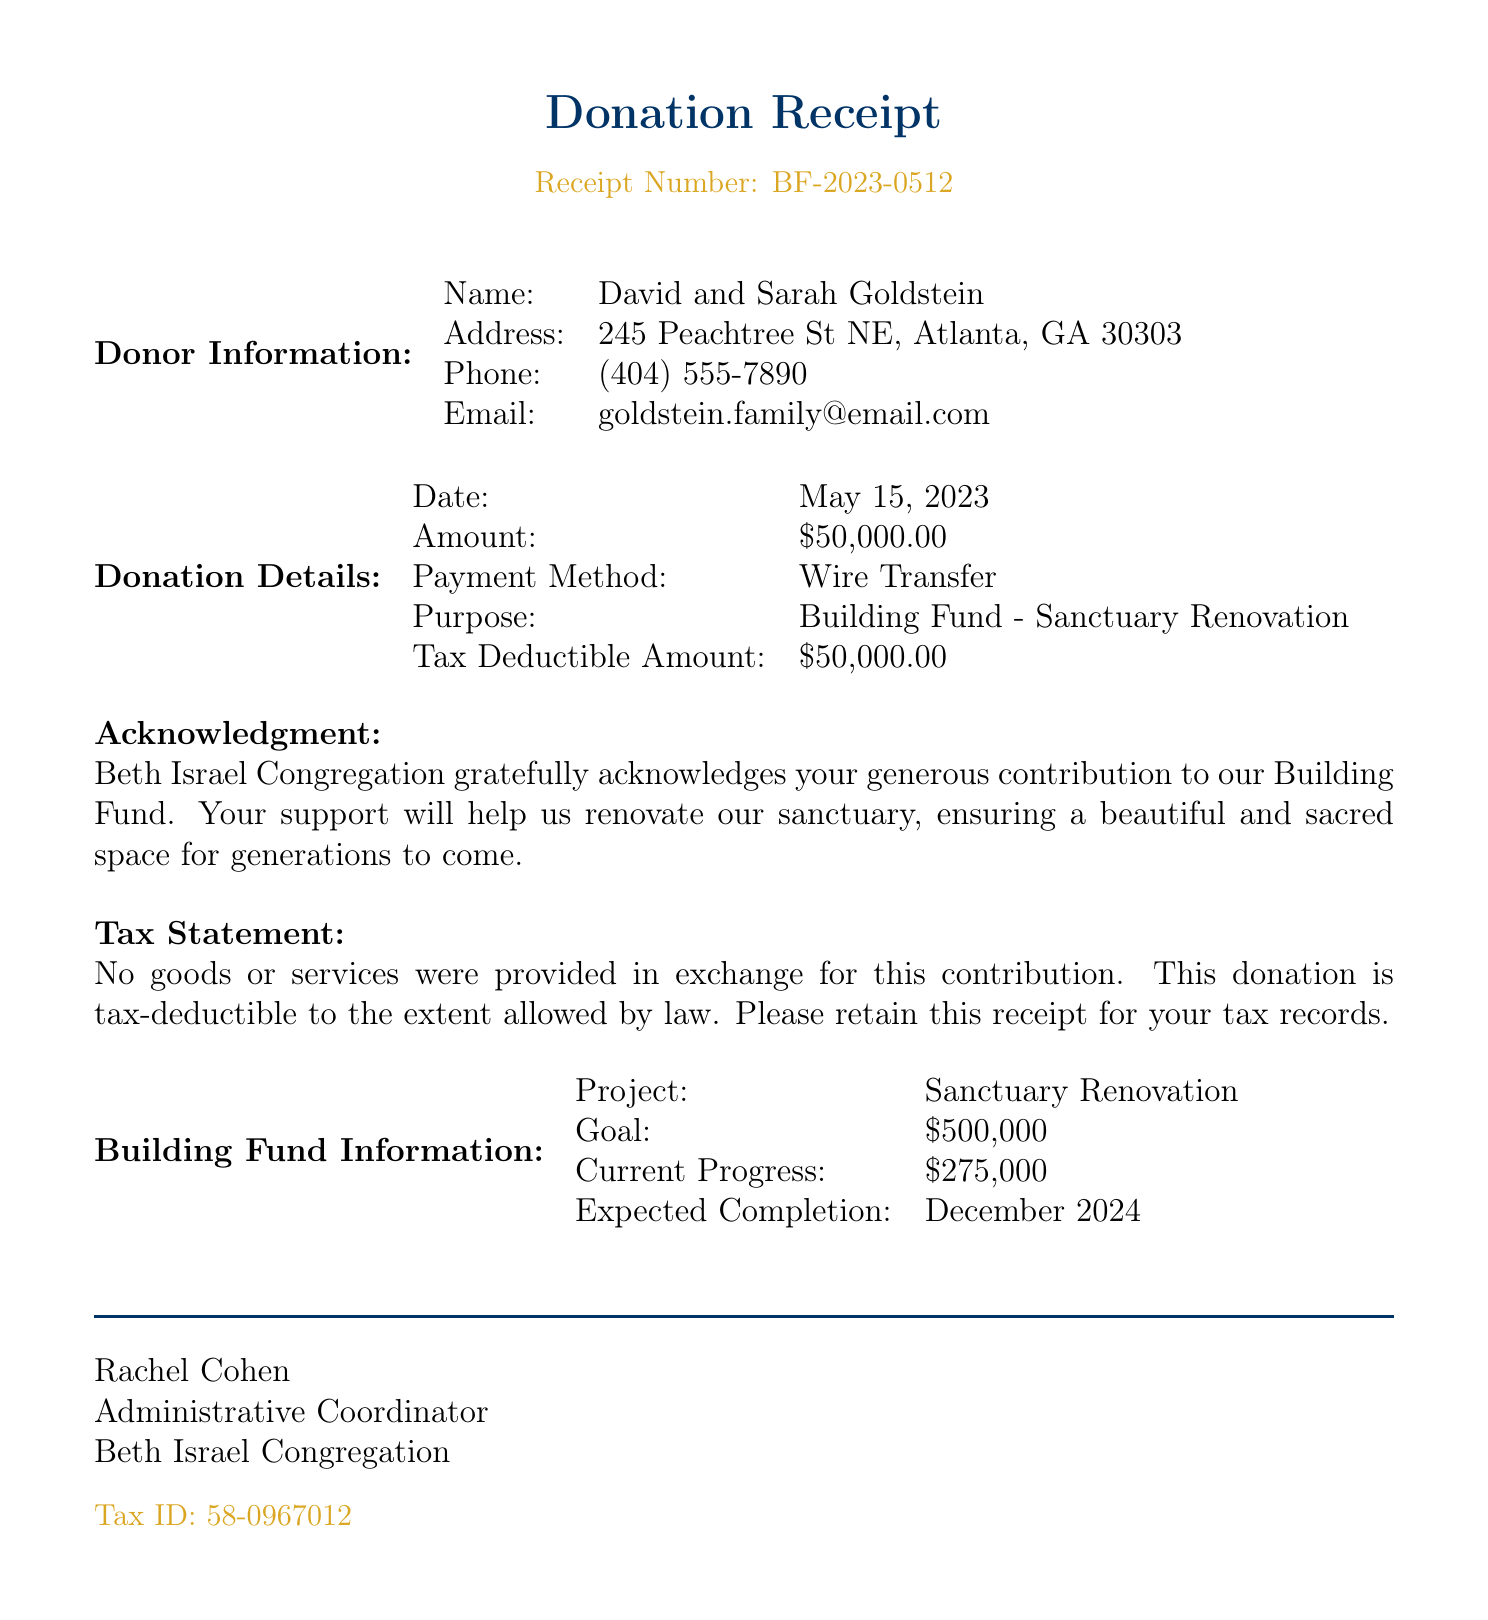What is the name of the synagogue? The name of the synagogue is specified in the document's header.
Answer: Beth Israel Congregation What is the address of the donor? The address of the donor is detailed under the donor information section.
Answer: 245 Peachtree St NE, Atlanta, GA 30303 What was the amount of the donation? The exact amount of the donation is explicitly listed in the donation details section.
Answer: $50,000.00 Who is the administrative coordinator? The administrative coordinator is mentioned in the acknowledgment section.
Answer: Rachel Cohen When was the donation made? The date of the donation is provided within the donation details section.
Answer: May 15, 2023 What is the purpose of the donation? The purpose is indicated in the donation details section which outlines the specific fund.
Answer: Building Fund - Sanctuary Renovation What is the total goal amount for the building fund? The total goal amount is specified in the building fund information section.
Answer: $500,000 How much has been raised so far for the building fund? The amount raised to date is detailed in the building fund information section.
Answer: $275,000 What is the expected completion date of the project? The expected completion date is provided in the building fund information section.
Answer: December 2024 